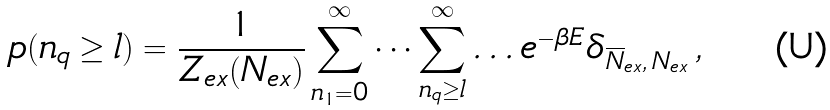Convert formula to latex. <formula><loc_0><loc_0><loc_500><loc_500>p ( n _ { q } \geq l ) = \frac { 1 } { Z _ { e x } ( N _ { e x } ) } \sum _ { n _ { 1 } = 0 } ^ { \infty } \dots \sum _ { n _ { q } \geq l } ^ { \infty } \dots e ^ { - \beta E } \delta _ { \overline { N } _ { e x } , \, N _ { e x } } \, ,</formula> 